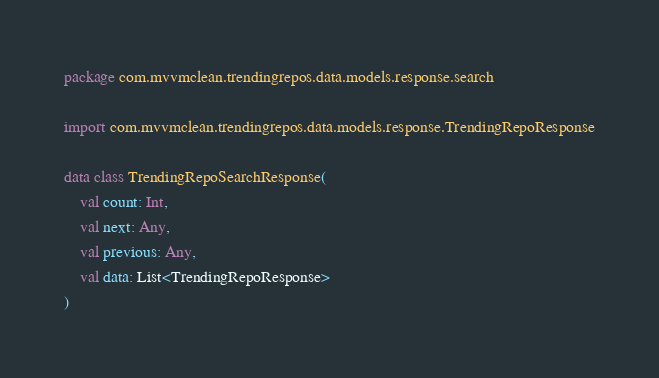Convert code to text. <code><loc_0><loc_0><loc_500><loc_500><_Kotlin_>package com.mvvmclean.trendingrepos.data.models.response.search

import com.mvvmclean.trendingrepos.data.models.response.TrendingRepoResponse

data class TrendingRepoSearchResponse(
    val count: Int,
    val next: Any,
    val previous: Any,
    val data: List<TrendingRepoResponse>
)</code> 